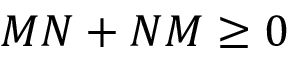Convert formula to latex. <formula><loc_0><loc_0><loc_500><loc_500>M N + N M \geq 0</formula> 